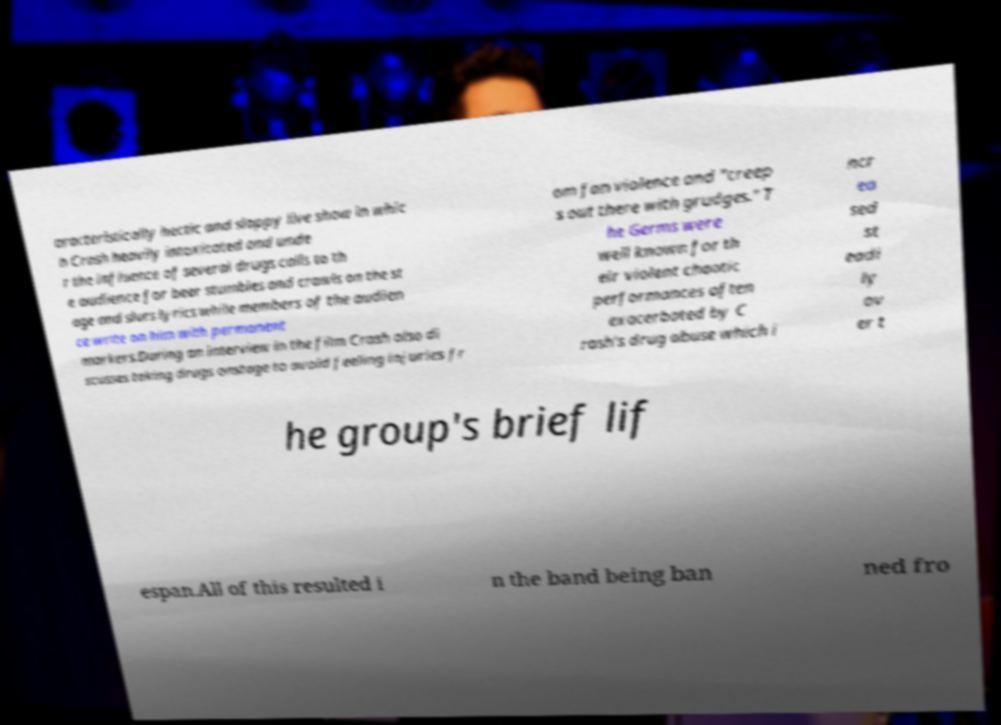What messages or text are displayed in this image? I need them in a readable, typed format. aracteristically hectic and sloppy live show in whic h Crash heavily intoxicated and unde r the influence of several drugs calls to th e audience for beer stumbles and crawls on the st age and slurs lyrics while members of the audien ce write on him with permanent markers.During an interview in the film Crash also di scusses taking drugs onstage to avoid feeling injuries fr om fan violence and "creep s out there with grudges." T he Germs were well known for th eir violent chaotic performances often exacerbated by C rash's drug abuse which i ncr ea sed st eadi ly ov er t he group's brief lif espan.All of this resulted i n the band being ban ned fro 